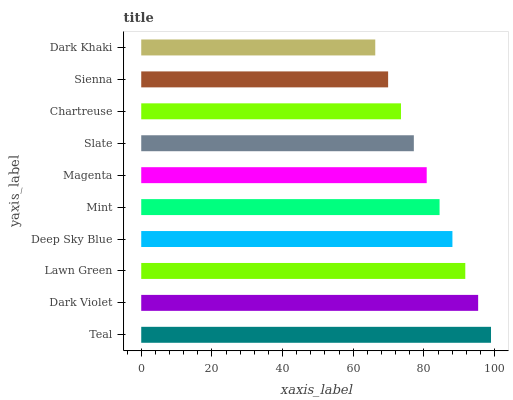Is Dark Khaki the minimum?
Answer yes or no. Yes. Is Teal the maximum?
Answer yes or no. Yes. Is Dark Violet the minimum?
Answer yes or no. No. Is Dark Violet the maximum?
Answer yes or no. No. Is Teal greater than Dark Violet?
Answer yes or no. Yes. Is Dark Violet less than Teal?
Answer yes or no. Yes. Is Dark Violet greater than Teal?
Answer yes or no. No. Is Teal less than Dark Violet?
Answer yes or no. No. Is Mint the high median?
Answer yes or no. Yes. Is Magenta the low median?
Answer yes or no. Yes. Is Dark Violet the high median?
Answer yes or no. No. Is Deep Sky Blue the low median?
Answer yes or no. No. 